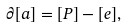Convert formula to latex. <formula><loc_0><loc_0><loc_500><loc_500>\partial [ a ] = [ P ] - [ e ] ,</formula> 